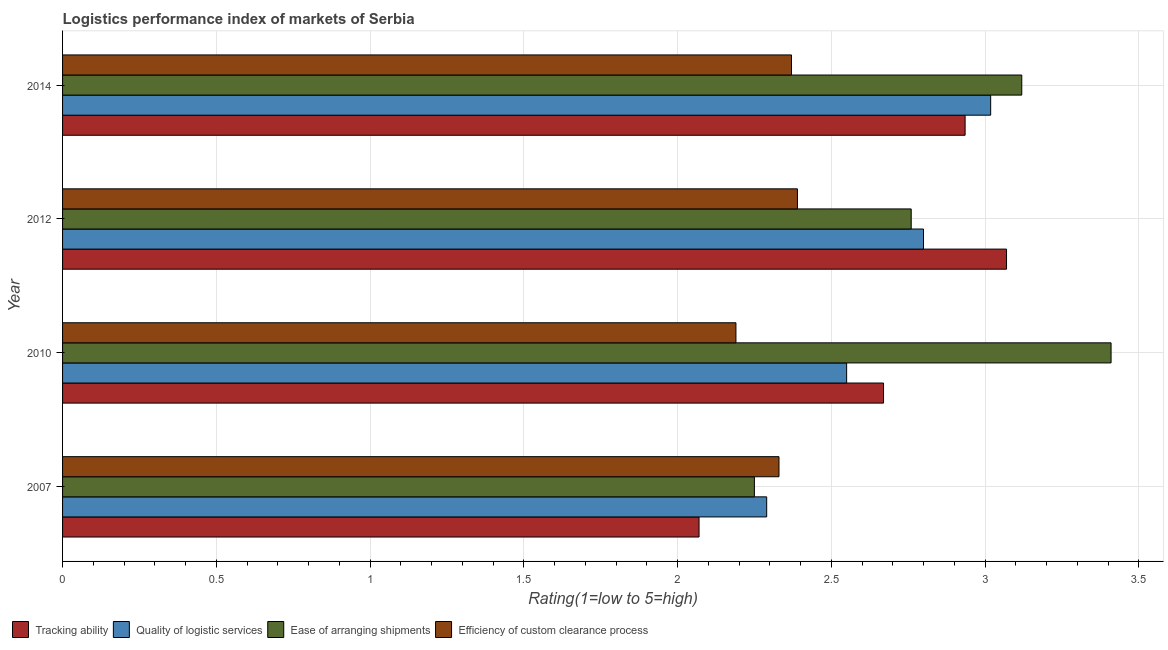How many groups of bars are there?
Give a very brief answer. 4. Are the number of bars per tick equal to the number of legend labels?
Your response must be concise. Yes. In how many cases, is the number of bars for a given year not equal to the number of legend labels?
Your response must be concise. 0. What is the lpi rating of efficiency of custom clearance process in 2012?
Your answer should be very brief. 2.39. Across all years, what is the maximum lpi rating of efficiency of custom clearance process?
Offer a very short reply. 2.39. Across all years, what is the minimum lpi rating of quality of logistic services?
Offer a very short reply. 2.29. What is the total lpi rating of ease of arranging shipments in the graph?
Make the answer very short. 11.54. What is the difference between the lpi rating of efficiency of custom clearance process in 2010 and that in 2012?
Provide a short and direct response. -0.2. What is the difference between the lpi rating of ease of arranging shipments in 2010 and the lpi rating of tracking ability in 2007?
Give a very brief answer. 1.34. What is the average lpi rating of efficiency of custom clearance process per year?
Your answer should be compact. 2.32. In the year 2010, what is the difference between the lpi rating of quality of logistic services and lpi rating of efficiency of custom clearance process?
Offer a terse response. 0.36. In how many years, is the lpi rating of efficiency of custom clearance process greater than 2.2 ?
Your response must be concise. 3. What is the ratio of the lpi rating of efficiency of custom clearance process in 2010 to that in 2014?
Make the answer very short. 0.92. Is the lpi rating of efficiency of custom clearance process in 2007 less than that in 2014?
Make the answer very short. Yes. What is the difference between the highest and the second highest lpi rating of tracking ability?
Provide a short and direct response. 0.14. Is the sum of the lpi rating of tracking ability in 2007 and 2014 greater than the maximum lpi rating of ease of arranging shipments across all years?
Offer a very short reply. Yes. Is it the case that in every year, the sum of the lpi rating of quality of logistic services and lpi rating of efficiency of custom clearance process is greater than the sum of lpi rating of tracking ability and lpi rating of ease of arranging shipments?
Your answer should be compact. No. What does the 2nd bar from the top in 2014 represents?
Offer a very short reply. Ease of arranging shipments. What does the 4th bar from the bottom in 2014 represents?
Make the answer very short. Efficiency of custom clearance process. What is the difference between two consecutive major ticks on the X-axis?
Give a very brief answer. 0.5. Does the graph contain any zero values?
Ensure brevity in your answer.  No. Where does the legend appear in the graph?
Offer a very short reply. Bottom left. How many legend labels are there?
Keep it short and to the point. 4. How are the legend labels stacked?
Offer a terse response. Horizontal. What is the title of the graph?
Give a very brief answer. Logistics performance index of markets of Serbia. Does "Germany" appear as one of the legend labels in the graph?
Give a very brief answer. No. What is the label or title of the X-axis?
Your response must be concise. Rating(1=low to 5=high). What is the Rating(1=low to 5=high) in Tracking ability in 2007?
Offer a terse response. 2.07. What is the Rating(1=low to 5=high) in Quality of logistic services in 2007?
Provide a short and direct response. 2.29. What is the Rating(1=low to 5=high) of Ease of arranging shipments in 2007?
Provide a succinct answer. 2.25. What is the Rating(1=low to 5=high) of Efficiency of custom clearance process in 2007?
Ensure brevity in your answer.  2.33. What is the Rating(1=low to 5=high) of Tracking ability in 2010?
Your answer should be compact. 2.67. What is the Rating(1=low to 5=high) in Quality of logistic services in 2010?
Your response must be concise. 2.55. What is the Rating(1=low to 5=high) of Ease of arranging shipments in 2010?
Provide a succinct answer. 3.41. What is the Rating(1=low to 5=high) in Efficiency of custom clearance process in 2010?
Your answer should be very brief. 2.19. What is the Rating(1=low to 5=high) of Tracking ability in 2012?
Keep it short and to the point. 3.07. What is the Rating(1=low to 5=high) in Ease of arranging shipments in 2012?
Your response must be concise. 2.76. What is the Rating(1=low to 5=high) of Efficiency of custom clearance process in 2012?
Make the answer very short. 2.39. What is the Rating(1=low to 5=high) of Tracking ability in 2014?
Offer a terse response. 2.94. What is the Rating(1=low to 5=high) of Quality of logistic services in 2014?
Your response must be concise. 3.02. What is the Rating(1=low to 5=high) of Ease of arranging shipments in 2014?
Your answer should be very brief. 3.12. What is the Rating(1=low to 5=high) in Efficiency of custom clearance process in 2014?
Provide a succinct answer. 2.37. Across all years, what is the maximum Rating(1=low to 5=high) of Tracking ability?
Your response must be concise. 3.07. Across all years, what is the maximum Rating(1=low to 5=high) in Quality of logistic services?
Keep it short and to the point. 3.02. Across all years, what is the maximum Rating(1=low to 5=high) of Ease of arranging shipments?
Provide a short and direct response. 3.41. Across all years, what is the maximum Rating(1=low to 5=high) of Efficiency of custom clearance process?
Give a very brief answer. 2.39. Across all years, what is the minimum Rating(1=low to 5=high) in Tracking ability?
Your response must be concise. 2.07. Across all years, what is the minimum Rating(1=low to 5=high) of Quality of logistic services?
Keep it short and to the point. 2.29. Across all years, what is the minimum Rating(1=low to 5=high) in Ease of arranging shipments?
Offer a very short reply. 2.25. Across all years, what is the minimum Rating(1=low to 5=high) in Efficiency of custom clearance process?
Offer a very short reply. 2.19. What is the total Rating(1=low to 5=high) of Tracking ability in the graph?
Offer a terse response. 10.75. What is the total Rating(1=low to 5=high) of Quality of logistic services in the graph?
Offer a very short reply. 10.66. What is the total Rating(1=low to 5=high) of Ease of arranging shipments in the graph?
Give a very brief answer. 11.54. What is the total Rating(1=low to 5=high) of Efficiency of custom clearance process in the graph?
Provide a short and direct response. 9.28. What is the difference between the Rating(1=low to 5=high) of Tracking ability in 2007 and that in 2010?
Offer a very short reply. -0.6. What is the difference between the Rating(1=low to 5=high) of Quality of logistic services in 2007 and that in 2010?
Your answer should be compact. -0.26. What is the difference between the Rating(1=low to 5=high) of Ease of arranging shipments in 2007 and that in 2010?
Provide a succinct answer. -1.16. What is the difference between the Rating(1=low to 5=high) of Efficiency of custom clearance process in 2007 and that in 2010?
Offer a terse response. 0.14. What is the difference between the Rating(1=low to 5=high) of Quality of logistic services in 2007 and that in 2012?
Ensure brevity in your answer.  -0.51. What is the difference between the Rating(1=low to 5=high) of Ease of arranging shipments in 2007 and that in 2012?
Your response must be concise. -0.51. What is the difference between the Rating(1=low to 5=high) in Efficiency of custom clearance process in 2007 and that in 2012?
Make the answer very short. -0.06. What is the difference between the Rating(1=low to 5=high) of Tracking ability in 2007 and that in 2014?
Ensure brevity in your answer.  -0.87. What is the difference between the Rating(1=low to 5=high) of Quality of logistic services in 2007 and that in 2014?
Make the answer very short. -0.73. What is the difference between the Rating(1=low to 5=high) of Ease of arranging shipments in 2007 and that in 2014?
Ensure brevity in your answer.  -0.87. What is the difference between the Rating(1=low to 5=high) of Efficiency of custom clearance process in 2007 and that in 2014?
Provide a short and direct response. -0.04. What is the difference between the Rating(1=low to 5=high) of Tracking ability in 2010 and that in 2012?
Keep it short and to the point. -0.4. What is the difference between the Rating(1=low to 5=high) of Quality of logistic services in 2010 and that in 2012?
Keep it short and to the point. -0.25. What is the difference between the Rating(1=low to 5=high) in Ease of arranging shipments in 2010 and that in 2012?
Provide a succinct answer. 0.65. What is the difference between the Rating(1=low to 5=high) in Efficiency of custom clearance process in 2010 and that in 2012?
Your answer should be very brief. -0.2. What is the difference between the Rating(1=low to 5=high) in Tracking ability in 2010 and that in 2014?
Ensure brevity in your answer.  -0.27. What is the difference between the Rating(1=low to 5=high) in Quality of logistic services in 2010 and that in 2014?
Give a very brief answer. -0.47. What is the difference between the Rating(1=low to 5=high) of Ease of arranging shipments in 2010 and that in 2014?
Offer a very short reply. 0.29. What is the difference between the Rating(1=low to 5=high) in Efficiency of custom clearance process in 2010 and that in 2014?
Offer a terse response. -0.18. What is the difference between the Rating(1=low to 5=high) of Tracking ability in 2012 and that in 2014?
Keep it short and to the point. 0.13. What is the difference between the Rating(1=low to 5=high) in Quality of logistic services in 2012 and that in 2014?
Keep it short and to the point. -0.22. What is the difference between the Rating(1=low to 5=high) in Ease of arranging shipments in 2012 and that in 2014?
Your response must be concise. -0.36. What is the difference between the Rating(1=low to 5=high) of Efficiency of custom clearance process in 2012 and that in 2014?
Ensure brevity in your answer.  0.02. What is the difference between the Rating(1=low to 5=high) in Tracking ability in 2007 and the Rating(1=low to 5=high) in Quality of logistic services in 2010?
Make the answer very short. -0.48. What is the difference between the Rating(1=low to 5=high) in Tracking ability in 2007 and the Rating(1=low to 5=high) in Ease of arranging shipments in 2010?
Your response must be concise. -1.34. What is the difference between the Rating(1=low to 5=high) in Tracking ability in 2007 and the Rating(1=low to 5=high) in Efficiency of custom clearance process in 2010?
Provide a short and direct response. -0.12. What is the difference between the Rating(1=low to 5=high) of Quality of logistic services in 2007 and the Rating(1=low to 5=high) of Ease of arranging shipments in 2010?
Make the answer very short. -1.12. What is the difference between the Rating(1=low to 5=high) in Quality of logistic services in 2007 and the Rating(1=low to 5=high) in Efficiency of custom clearance process in 2010?
Offer a very short reply. 0.1. What is the difference between the Rating(1=low to 5=high) of Ease of arranging shipments in 2007 and the Rating(1=low to 5=high) of Efficiency of custom clearance process in 2010?
Ensure brevity in your answer.  0.06. What is the difference between the Rating(1=low to 5=high) in Tracking ability in 2007 and the Rating(1=low to 5=high) in Quality of logistic services in 2012?
Provide a short and direct response. -0.73. What is the difference between the Rating(1=low to 5=high) in Tracking ability in 2007 and the Rating(1=low to 5=high) in Ease of arranging shipments in 2012?
Your answer should be very brief. -0.69. What is the difference between the Rating(1=low to 5=high) in Tracking ability in 2007 and the Rating(1=low to 5=high) in Efficiency of custom clearance process in 2012?
Make the answer very short. -0.32. What is the difference between the Rating(1=low to 5=high) of Quality of logistic services in 2007 and the Rating(1=low to 5=high) of Ease of arranging shipments in 2012?
Ensure brevity in your answer.  -0.47. What is the difference between the Rating(1=low to 5=high) of Ease of arranging shipments in 2007 and the Rating(1=low to 5=high) of Efficiency of custom clearance process in 2012?
Provide a short and direct response. -0.14. What is the difference between the Rating(1=low to 5=high) of Tracking ability in 2007 and the Rating(1=low to 5=high) of Quality of logistic services in 2014?
Provide a short and direct response. -0.95. What is the difference between the Rating(1=low to 5=high) of Tracking ability in 2007 and the Rating(1=low to 5=high) of Ease of arranging shipments in 2014?
Provide a short and direct response. -1.05. What is the difference between the Rating(1=low to 5=high) in Tracking ability in 2007 and the Rating(1=low to 5=high) in Efficiency of custom clearance process in 2014?
Your answer should be compact. -0.3. What is the difference between the Rating(1=low to 5=high) in Quality of logistic services in 2007 and the Rating(1=low to 5=high) in Ease of arranging shipments in 2014?
Keep it short and to the point. -0.83. What is the difference between the Rating(1=low to 5=high) in Quality of logistic services in 2007 and the Rating(1=low to 5=high) in Efficiency of custom clearance process in 2014?
Give a very brief answer. -0.08. What is the difference between the Rating(1=low to 5=high) in Ease of arranging shipments in 2007 and the Rating(1=low to 5=high) in Efficiency of custom clearance process in 2014?
Offer a terse response. -0.12. What is the difference between the Rating(1=low to 5=high) in Tracking ability in 2010 and the Rating(1=low to 5=high) in Quality of logistic services in 2012?
Make the answer very short. -0.13. What is the difference between the Rating(1=low to 5=high) of Tracking ability in 2010 and the Rating(1=low to 5=high) of Ease of arranging shipments in 2012?
Keep it short and to the point. -0.09. What is the difference between the Rating(1=low to 5=high) of Tracking ability in 2010 and the Rating(1=low to 5=high) of Efficiency of custom clearance process in 2012?
Your answer should be very brief. 0.28. What is the difference between the Rating(1=low to 5=high) in Quality of logistic services in 2010 and the Rating(1=low to 5=high) in Ease of arranging shipments in 2012?
Your answer should be compact. -0.21. What is the difference between the Rating(1=low to 5=high) in Quality of logistic services in 2010 and the Rating(1=low to 5=high) in Efficiency of custom clearance process in 2012?
Provide a short and direct response. 0.16. What is the difference between the Rating(1=low to 5=high) in Ease of arranging shipments in 2010 and the Rating(1=low to 5=high) in Efficiency of custom clearance process in 2012?
Provide a succinct answer. 1.02. What is the difference between the Rating(1=low to 5=high) in Tracking ability in 2010 and the Rating(1=low to 5=high) in Quality of logistic services in 2014?
Provide a succinct answer. -0.35. What is the difference between the Rating(1=low to 5=high) in Tracking ability in 2010 and the Rating(1=low to 5=high) in Ease of arranging shipments in 2014?
Offer a terse response. -0.45. What is the difference between the Rating(1=low to 5=high) in Tracking ability in 2010 and the Rating(1=low to 5=high) in Efficiency of custom clearance process in 2014?
Ensure brevity in your answer.  0.3. What is the difference between the Rating(1=low to 5=high) of Quality of logistic services in 2010 and the Rating(1=low to 5=high) of Ease of arranging shipments in 2014?
Make the answer very short. -0.57. What is the difference between the Rating(1=low to 5=high) of Quality of logistic services in 2010 and the Rating(1=low to 5=high) of Efficiency of custom clearance process in 2014?
Offer a terse response. 0.18. What is the difference between the Rating(1=low to 5=high) in Ease of arranging shipments in 2010 and the Rating(1=low to 5=high) in Efficiency of custom clearance process in 2014?
Give a very brief answer. 1.04. What is the difference between the Rating(1=low to 5=high) in Tracking ability in 2012 and the Rating(1=low to 5=high) in Quality of logistic services in 2014?
Offer a very short reply. 0.05. What is the difference between the Rating(1=low to 5=high) in Tracking ability in 2012 and the Rating(1=low to 5=high) in Ease of arranging shipments in 2014?
Your answer should be very brief. -0.05. What is the difference between the Rating(1=low to 5=high) in Tracking ability in 2012 and the Rating(1=low to 5=high) in Efficiency of custom clearance process in 2014?
Your answer should be very brief. 0.7. What is the difference between the Rating(1=low to 5=high) in Quality of logistic services in 2012 and the Rating(1=low to 5=high) in Ease of arranging shipments in 2014?
Your response must be concise. -0.32. What is the difference between the Rating(1=low to 5=high) of Quality of logistic services in 2012 and the Rating(1=low to 5=high) of Efficiency of custom clearance process in 2014?
Offer a terse response. 0.43. What is the difference between the Rating(1=low to 5=high) of Ease of arranging shipments in 2012 and the Rating(1=low to 5=high) of Efficiency of custom clearance process in 2014?
Keep it short and to the point. 0.39. What is the average Rating(1=low to 5=high) in Tracking ability per year?
Provide a short and direct response. 2.69. What is the average Rating(1=low to 5=high) of Quality of logistic services per year?
Your answer should be very brief. 2.66. What is the average Rating(1=low to 5=high) in Ease of arranging shipments per year?
Your answer should be very brief. 2.88. What is the average Rating(1=low to 5=high) in Efficiency of custom clearance process per year?
Keep it short and to the point. 2.32. In the year 2007, what is the difference between the Rating(1=low to 5=high) in Tracking ability and Rating(1=low to 5=high) in Quality of logistic services?
Make the answer very short. -0.22. In the year 2007, what is the difference between the Rating(1=low to 5=high) in Tracking ability and Rating(1=low to 5=high) in Ease of arranging shipments?
Give a very brief answer. -0.18. In the year 2007, what is the difference between the Rating(1=low to 5=high) in Tracking ability and Rating(1=low to 5=high) in Efficiency of custom clearance process?
Your answer should be very brief. -0.26. In the year 2007, what is the difference between the Rating(1=low to 5=high) in Quality of logistic services and Rating(1=low to 5=high) in Ease of arranging shipments?
Provide a succinct answer. 0.04. In the year 2007, what is the difference between the Rating(1=low to 5=high) of Quality of logistic services and Rating(1=low to 5=high) of Efficiency of custom clearance process?
Your response must be concise. -0.04. In the year 2007, what is the difference between the Rating(1=low to 5=high) of Ease of arranging shipments and Rating(1=low to 5=high) of Efficiency of custom clearance process?
Ensure brevity in your answer.  -0.08. In the year 2010, what is the difference between the Rating(1=low to 5=high) in Tracking ability and Rating(1=low to 5=high) in Quality of logistic services?
Provide a succinct answer. 0.12. In the year 2010, what is the difference between the Rating(1=low to 5=high) in Tracking ability and Rating(1=low to 5=high) in Ease of arranging shipments?
Give a very brief answer. -0.74. In the year 2010, what is the difference between the Rating(1=low to 5=high) of Tracking ability and Rating(1=low to 5=high) of Efficiency of custom clearance process?
Provide a short and direct response. 0.48. In the year 2010, what is the difference between the Rating(1=low to 5=high) in Quality of logistic services and Rating(1=low to 5=high) in Ease of arranging shipments?
Give a very brief answer. -0.86. In the year 2010, what is the difference between the Rating(1=low to 5=high) in Quality of logistic services and Rating(1=low to 5=high) in Efficiency of custom clearance process?
Make the answer very short. 0.36. In the year 2010, what is the difference between the Rating(1=low to 5=high) in Ease of arranging shipments and Rating(1=low to 5=high) in Efficiency of custom clearance process?
Your answer should be very brief. 1.22. In the year 2012, what is the difference between the Rating(1=low to 5=high) of Tracking ability and Rating(1=low to 5=high) of Quality of logistic services?
Your answer should be very brief. 0.27. In the year 2012, what is the difference between the Rating(1=low to 5=high) of Tracking ability and Rating(1=low to 5=high) of Ease of arranging shipments?
Give a very brief answer. 0.31. In the year 2012, what is the difference between the Rating(1=low to 5=high) in Tracking ability and Rating(1=low to 5=high) in Efficiency of custom clearance process?
Your answer should be compact. 0.68. In the year 2012, what is the difference between the Rating(1=low to 5=high) in Quality of logistic services and Rating(1=low to 5=high) in Ease of arranging shipments?
Provide a succinct answer. 0.04. In the year 2012, what is the difference between the Rating(1=low to 5=high) of Quality of logistic services and Rating(1=low to 5=high) of Efficiency of custom clearance process?
Make the answer very short. 0.41. In the year 2012, what is the difference between the Rating(1=low to 5=high) of Ease of arranging shipments and Rating(1=low to 5=high) of Efficiency of custom clearance process?
Provide a succinct answer. 0.37. In the year 2014, what is the difference between the Rating(1=low to 5=high) in Tracking ability and Rating(1=low to 5=high) in Quality of logistic services?
Your answer should be very brief. -0.08. In the year 2014, what is the difference between the Rating(1=low to 5=high) of Tracking ability and Rating(1=low to 5=high) of Ease of arranging shipments?
Give a very brief answer. -0.18. In the year 2014, what is the difference between the Rating(1=low to 5=high) in Tracking ability and Rating(1=low to 5=high) in Efficiency of custom clearance process?
Your answer should be very brief. 0.56. In the year 2014, what is the difference between the Rating(1=low to 5=high) of Quality of logistic services and Rating(1=low to 5=high) of Ease of arranging shipments?
Give a very brief answer. -0.1. In the year 2014, what is the difference between the Rating(1=low to 5=high) in Quality of logistic services and Rating(1=low to 5=high) in Efficiency of custom clearance process?
Offer a terse response. 0.65. In the year 2014, what is the difference between the Rating(1=low to 5=high) in Ease of arranging shipments and Rating(1=low to 5=high) in Efficiency of custom clearance process?
Provide a short and direct response. 0.75. What is the ratio of the Rating(1=low to 5=high) of Tracking ability in 2007 to that in 2010?
Your answer should be compact. 0.78. What is the ratio of the Rating(1=low to 5=high) in Quality of logistic services in 2007 to that in 2010?
Offer a terse response. 0.9. What is the ratio of the Rating(1=low to 5=high) of Ease of arranging shipments in 2007 to that in 2010?
Provide a succinct answer. 0.66. What is the ratio of the Rating(1=low to 5=high) of Efficiency of custom clearance process in 2007 to that in 2010?
Provide a short and direct response. 1.06. What is the ratio of the Rating(1=low to 5=high) of Tracking ability in 2007 to that in 2012?
Your response must be concise. 0.67. What is the ratio of the Rating(1=low to 5=high) of Quality of logistic services in 2007 to that in 2012?
Ensure brevity in your answer.  0.82. What is the ratio of the Rating(1=low to 5=high) in Ease of arranging shipments in 2007 to that in 2012?
Ensure brevity in your answer.  0.82. What is the ratio of the Rating(1=low to 5=high) in Efficiency of custom clearance process in 2007 to that in 2012?
Offer a terse response. 0.97. What is the ratio of the Rating(1=low to 5=high) of Tracking ability in 2007 to that in 2014?
Your response must be concise. 0.71. What is the ratio of the Rating(1=low to 5=high) in Quality of logistic services in 2007 to that in 2014?
Keep it short and to the point. 0.76. What is the ratio of the Rating(1=low to 5=high) of Ease of arranging shipments in 2007 to that in 2014?
Your answer should be very brief. 0.72. What is the ratio of the Rating(1=low to 5=high) in Efficiency of custom clearance process in 2007 to that in 2014?
Your answer should be very brief. 0.98. What is the ratio of the Rating(1=low to 5=high) of Tracking ability in 2010 to that in 2012?
Ensure brevity in your answer.  0.87. What is the ratio of the Rating(1=low to 5=high) of Quality of logistic services in 2010 to that in 2012?
Offer a very short reply. 0.91. What is the ratio of the Rating(1=low to 5=high) in Ease of arranging shipments in 2010 to that in 2012?
Offer a very short reply. 1.24. What is the ratio of the Rating(1=low to 5=high) in Efficiency of custom clearance process in 2010 to that in 2012?
Make the answer very short. 0.92. What is the ratio of the Rating(1=low to 5=high) in Tracking ability in 2010 to that in 2014?
Provide a short and direct response. 0.91. What is the ratio of the Rating(1=low to 5=high) in Quality of logistic services in 2010 to that in 2014?
Provide a short and direct response. 0.84. What is the ratio of the Rating(1=low to 5=high) in Ease of arranging shipments in 2010 to that in 2014?
Ensure brevity in your answer.  1.09. What is the ratio of the Rating(1=low to 5=high) of Efficiency of custom clearance process in 2010 to that in 2014?
Provide a succinct answer. 0.92. What is the ratio of the Rating(1=low to 5=high) of Tracking ability in 2012 to that in 2014?
Ensure brevity in your answer.  1.05. What is the ratio of the Rating(1=low to 5=high) in Quality of logistic services in 2012 to that in 2014?
Your answer should be compact. 0.93. What is the ratio of the Rating(1=low to 5=high) in Ease of arranging shipments in 2012 to that in 2014?
Your answer should be compact. 0.88. What is the ratio of the Rating(1=low to 5=high) of Efficiency of custom clearance process in 2012 to that in 2014?
Ensure brevity in your answer.  1.01. What is the difference between the highest and the second highest Rating(1=low to 5=high) of Tracking ability?
Your answer should be very brief. 0.13. What is the difference between the highest and the second highest Rating(1=low to 5=high) of Quality of logistic services?
Give a very brief answer. 0.22. What is the difference between the highest and the second highest Rating(1=low to 5=high) in Ease of arranging shipments?
Give a very brief answer. 0.29. What is the difference between the highest and the second highest Rating(1=low to 5=high) in Efficiency of custom clearance process?
Ensure brevity in your answer.  0.02. What is the difference between the highest and the lowest Rating(1=low to 5=high) in Quality of logistic services?
Your response must be concise. 0.73. What is the difference between the highest and the lowest Rating(1=low to 5=high) in Ease of arranging shipments?
Your answer should be very brief. 1.16. 